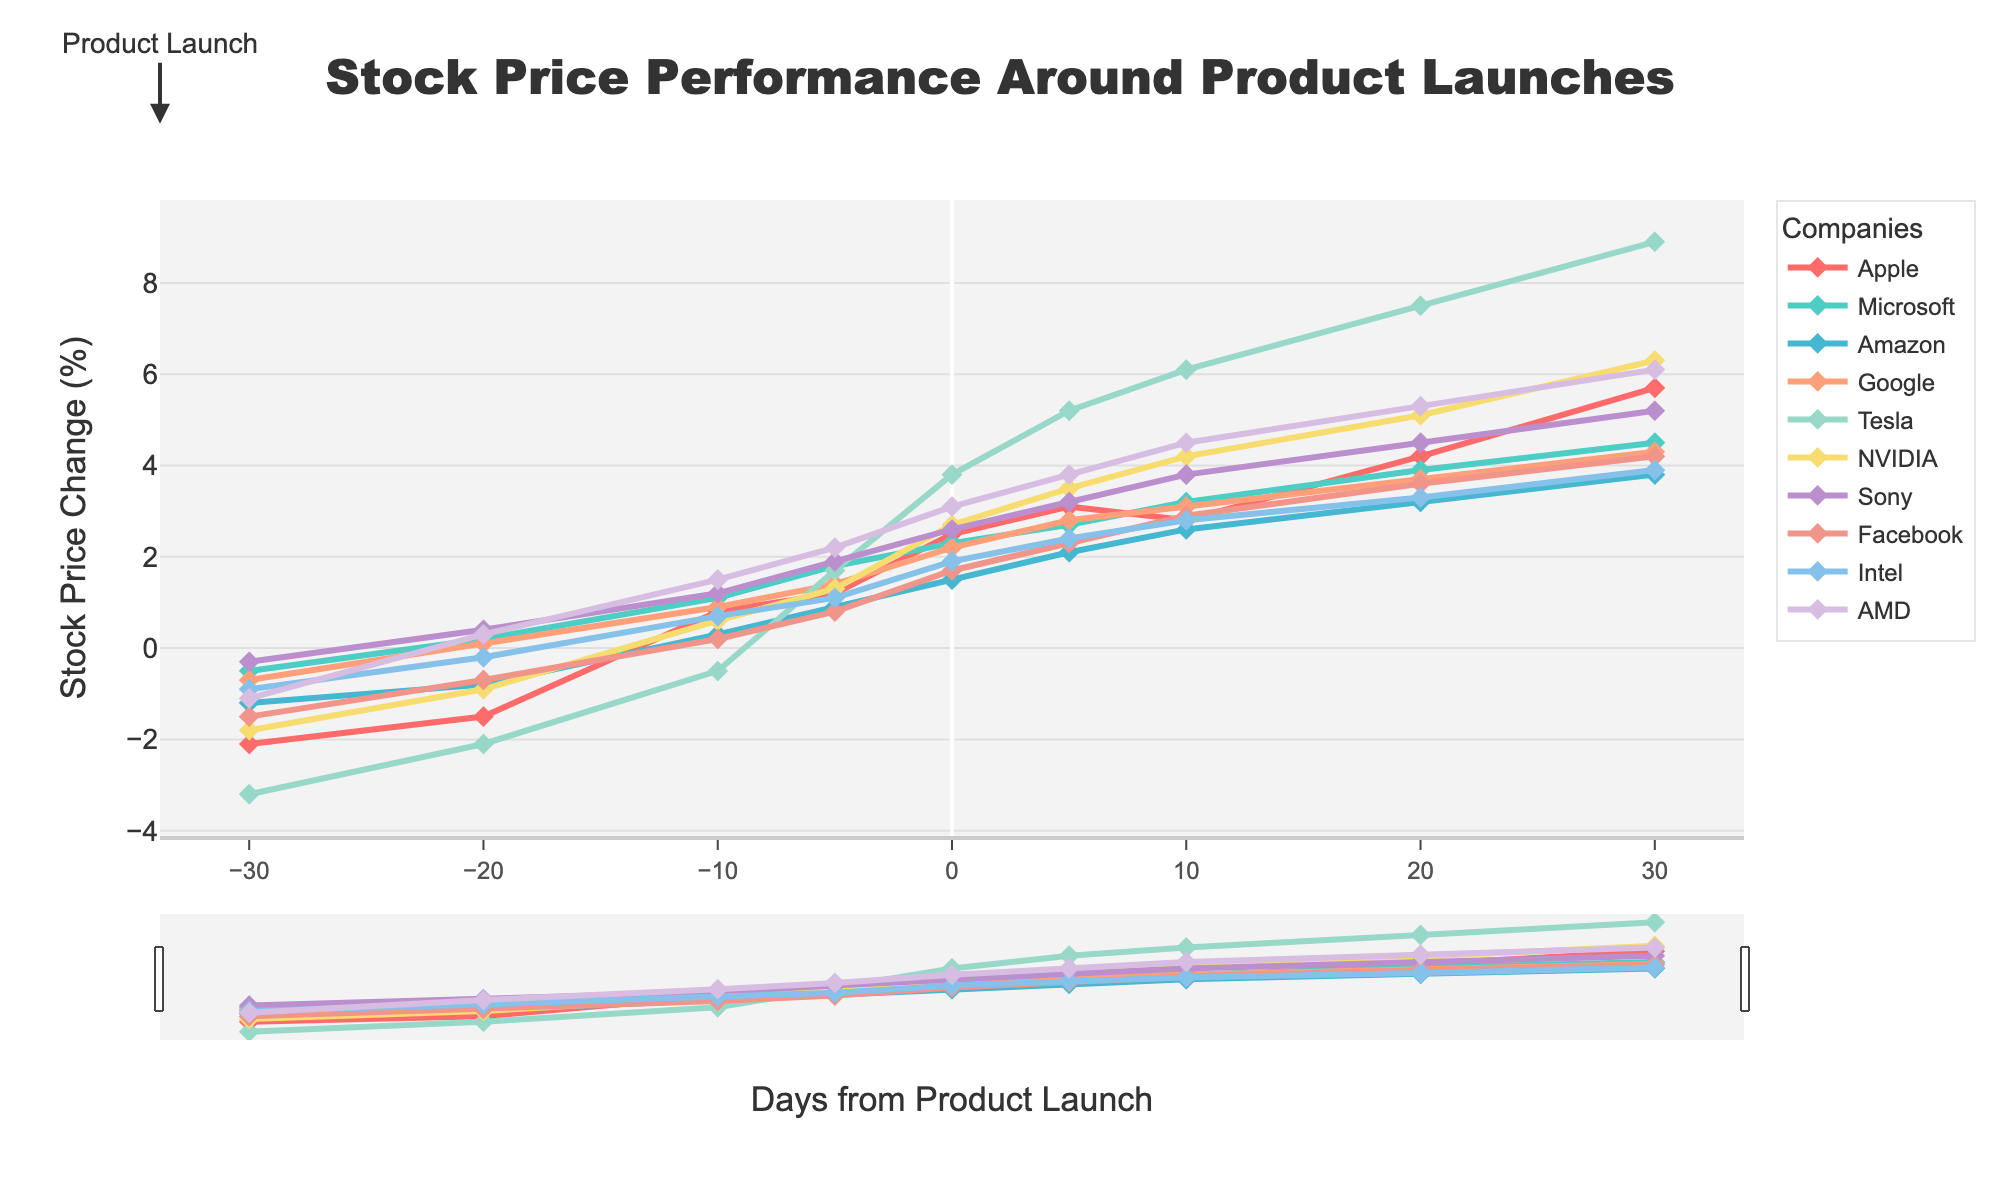What is the overall trend of Tesla's stock price post launch of Model Y? Tesla's stock price shows a significant upward trend after the launch date, starting from 3.8% on the launch day to 8.9% by 30 days post-launch.
Answer: Upward trend Which company's stock had the highest percentage increase by 30 days after product launch? By 30 days after the product launch, Tesla’s stock shows the highest increase at 8.9%.
Answer: Tesla Compare the stock performances of Apple and Microsoft 10 days post their product launches. Apple's stock increased by 2.8% while Microsoft's increased by 3.2% 10 days post-launch.
Answer: Microsoft's stock performance was better with a 3.2% increase compared to Apple’s 2.8% Between AMD and Google, whose stock experienced a higher percentage change on the launch day? On the launch day, AMD’s stock increased by 3.1% while Google’s stock increased by 2.2%.
Answer: AMD What is the average stock price change for NVIDIA from 10 days before to 10 days after the launch? The stock price changes for NVIDIA from 10 days before to 10 days after the launch are -0.9%, 0.6%, 1.3%, 2.7%, 3.5%, and 4.2%. The average of these values is (-0.9 + 0.6 + 1.3 + 2.7 + 3.5 + 4.2) / 6 = 1.57%.
Answer: 1.57% Which company has the steadiest increase in stock price, i.e., smallest variance from 0 to 30 days post-launch? To determine the smallest variance, we need to calculate the stock price change variance for each company from 0 to 30 days post-launch. Without calculation details, from visual observation, Intel shows the steadiest and most gradual increase.
Answer: Intel Overall, which day shows the most consistent performance increase across all companies? The stock prices seem to consistently increase for most companies on day 30 post-launch.
Answer: 30 days post-launch What was the cumulative stock price change for Facebook from 10 days before to 30 days after the launch? The stock price changes for Facebook in the specified period are: -0.7%, 0.2%, 0.8%, 1.7%, 2.3%, 2.9%, 3.6%, and 4.2%. The cumulative change is the sum: (-0.7 + 0.2 + 0.8 + 1.7 + 2.3 + 2.9 + 3.6 + 4.2) = 15%.
Answer: 15% Which company started off with a stock price decrease but ended up with a substantial price increase post-launch? Tesla's stock price decreased significantly pre-launch by -3.2%, but it increased substantially to 8.9% post-launch.
Answer: Tesla 